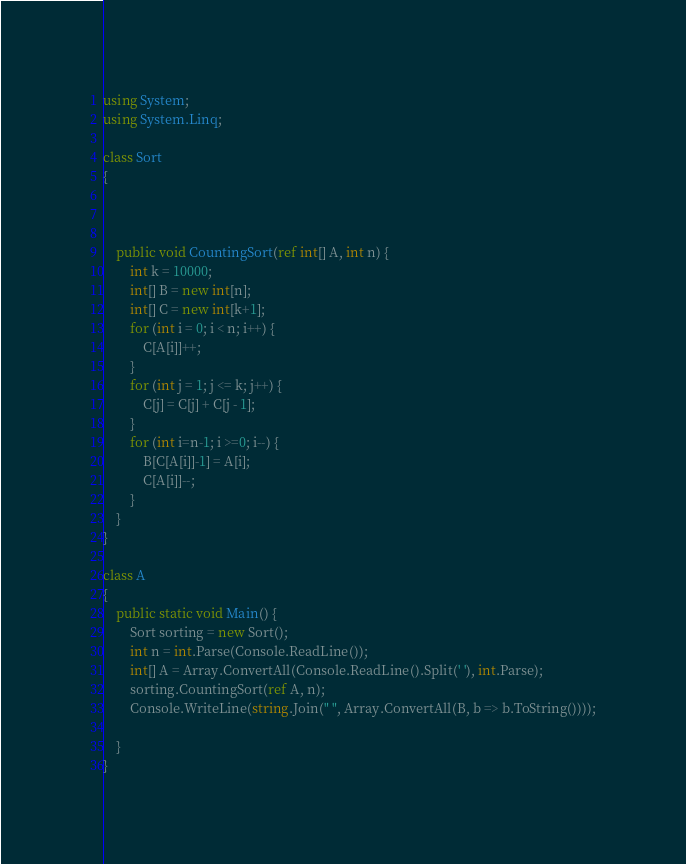Convert code to text. <code><loc_0><loc_0><loc_500><loc_500><_C#_>using System;
using System.Linq;

class Sort
{



    public void CountingSort(ref int[] A, int n) {
        int k = 10000;
        int[] B = new int[n];
        int[] C = new int[k+1];
        for (int i = 0; i < n; i++) {
            C[A[i]]++;
        }
        for (int j = 1; j <= k; j++) {
            C[j] = C[j] + C[j - 1];
        }
        for (int i=n-1; i >=0; i--) {
            B[C[A[i]]-1] = A[i];
            C[A[i]]--;
        }
    }
}

class A
{
    public static void Main() {
        Sort sorting = new Sort();
        int n = int.Parse(Console.ReadLine());
        int[] A = Array.ConvertAll(Console.ReadLine().Split(' '), int.Parse);
        sorting.CountingSort(ref A, n);
        Console.WriteLine(string.Join(" ", Array.ConvertAll(B, b => b.ToString())));

    }
}

</code> 